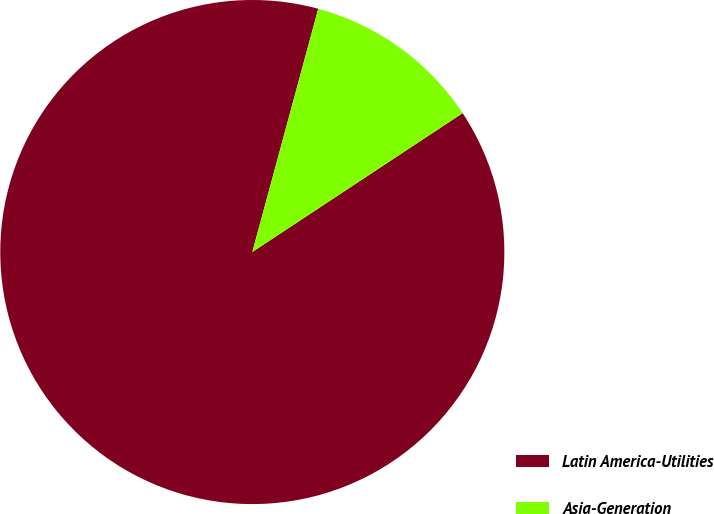Convert chart. <chart><loc_0><loc_0><loc_500><loc_500><pie_chart><fcel>Latin America-Utilities<fcel>Asia-Generation<nl><fcel>88.5%<fcel>11.5%<nl></chart> 